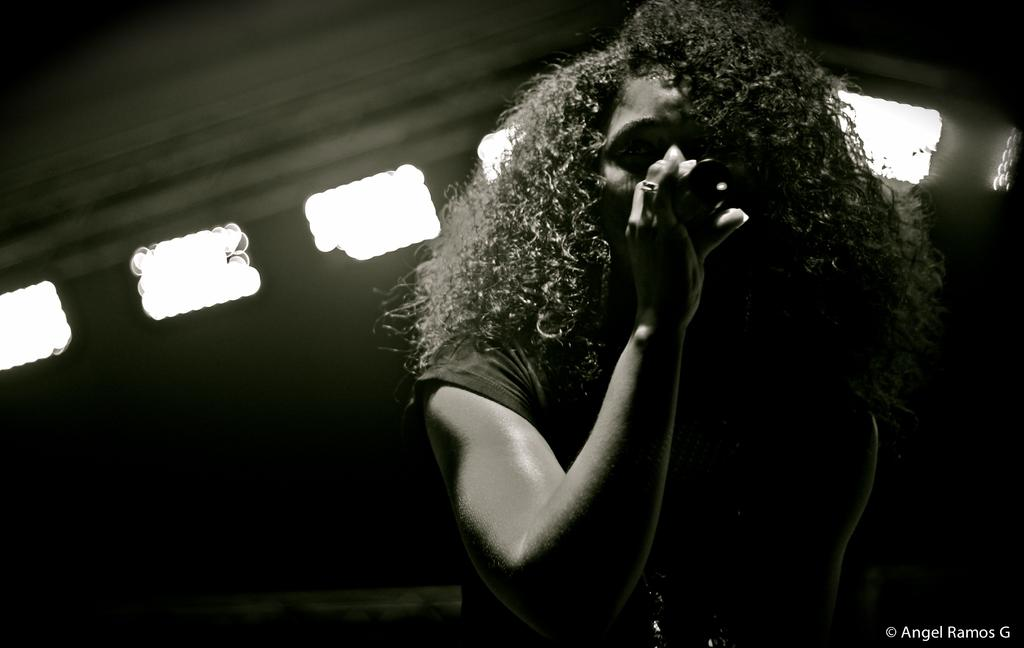What is the main subject in the foreground of the image? There is a person in the foreground of the image. What is the person holding in their hand? The person is holding a microphone in their hand. Can you describe any text visible in the image? Yes, there is text visible in the image. What can be seen in the background of the image? There are focus lights and a curtain in the background of the image. What might suggest that the image was taken in a specific setting? The image may have been taken on a stage, as there are focus lights and a curtain in the background. How many cards are being held by the person in the image? There are no cards visible in the image; the person is holding a microphone. What type of stem can be seen growing from the curtain in the background? There is no stem growing from the curtain in the background, as it is a curtain and not a plant. 